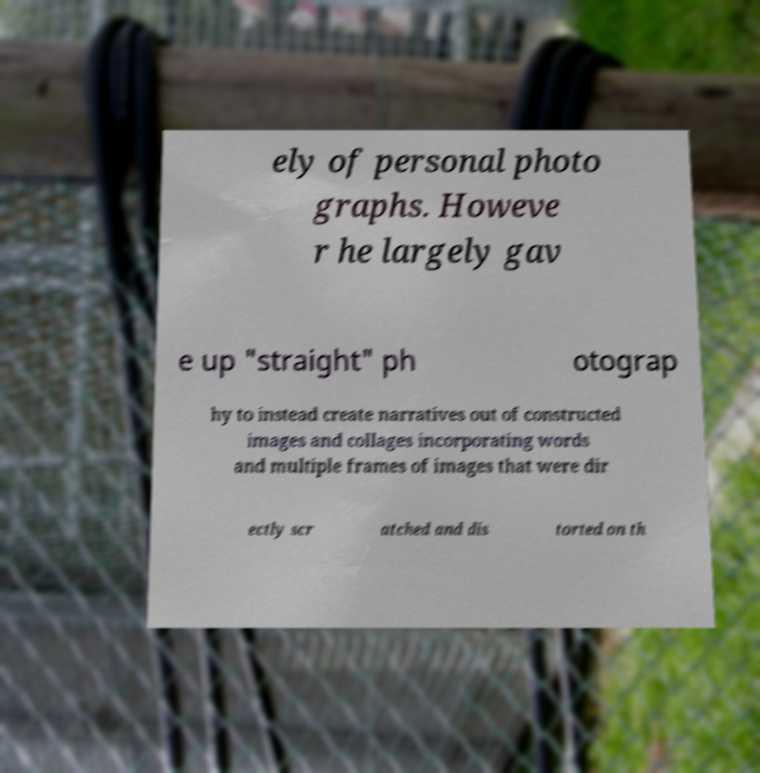Please read and relay the text visible in this image. What does it say? ely of personal photo graphs. Howeve r he largely gav e up "straight" ph otograp hy to instead create narratives out of constructed images and collages incorporating words and multiple frames of images that were dir ectly scr atched and dis torted on th 